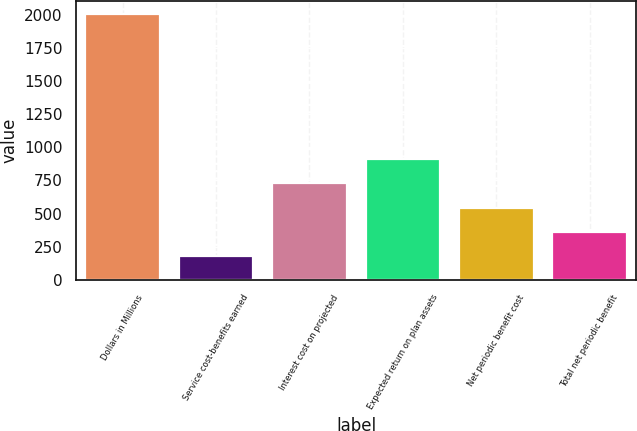Convert chart to OTSL. <chart><loc_0><loc_0><loc_500><loc_500><bar_chart><fcel>Dollars in Millions<fcel>Service cost-benefits earned<fcel>Interest cost on projected<fcel>Expected return on plan assets<fcel>Net periodic benefit cost<fcel>Total net periodic benefit<nl><fcel>2004<fcel>180<fcel>727.2<fcel>909.6<fcel>544.8<fcel>362.4<nl></chart> 